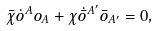<formula> <loc_0><loc_0><loc_500><loc_500>\bar { \chi } \dot { o } ^ { A } o _ { A } + \chi \dot { \bar { o } } ^ { A ^ { \prime } } \bar { o } _ { A ^ { \prime } } = 0 ,</formula> 